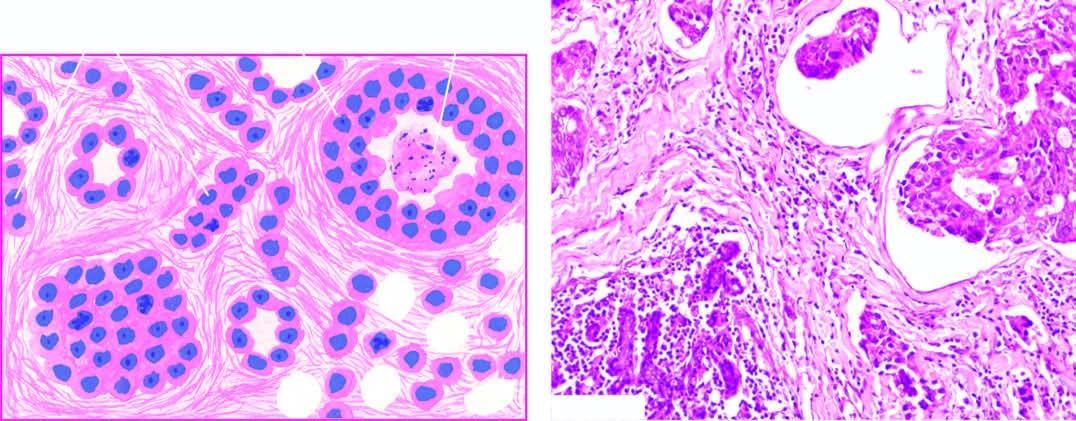what is there of densely collagenised stroma by these cells in a haphazard manner?
Answer the question using a single word or phrase. Infiltration 